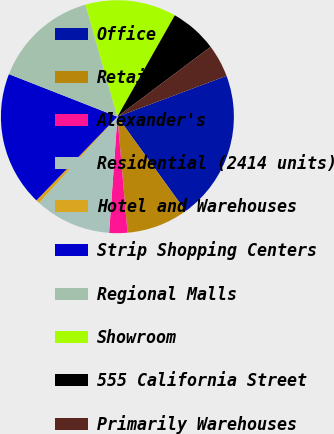<chart> <loc_0><loc_0><loc_500><loc_500><pie_chart><fcel>Office<fcel>Retail<fcel>Alexander's<fcel>Residential (2414 units)<fcel>Hotel and Warehouses<fcel>Strip Shopping Centers<fcel>Regional Malls<fcel>Showroom<fcel>555 California Street<fcel>Primarily Warehouses<nl><fcel>20.73%<fcel>8.58%<fcel>2.52%<fcel>10.6%<fcel>0.5%<fcel>18.71%<fcel>14.63%<fcel>12.62%<fcel>6.56%<fcel>4.54%<nl></chart> 